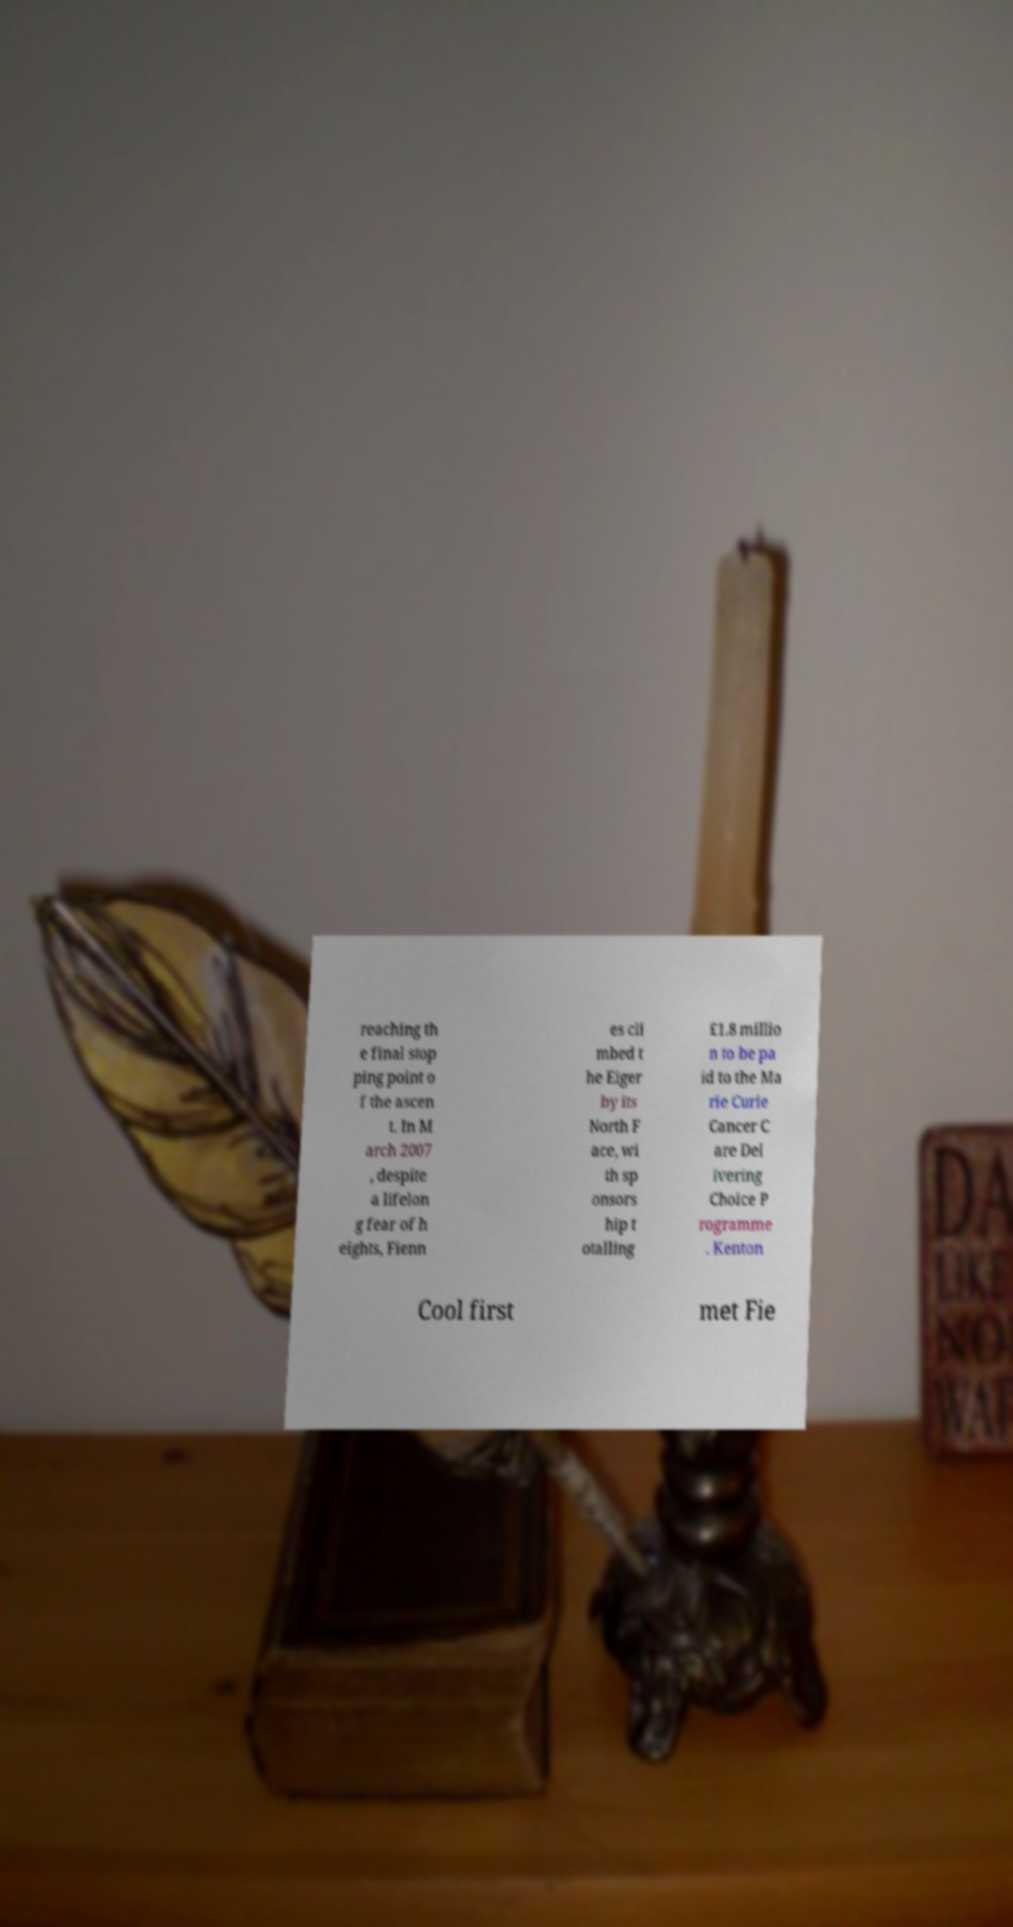Could you extract and type out the text from this image? reaching th e final stop ping point o f the ascen t. In M arch 2007 , despite a lifelon g fear of h eights, Fienn es cli mbed t he Eiger by its North F ace, wi th sp onsors hip t otalling £1.8 millio n to be pa id to the Ma rie Curie Cancer C are Del ivering Choice P rogramme . Kenton Cool first met Fie 